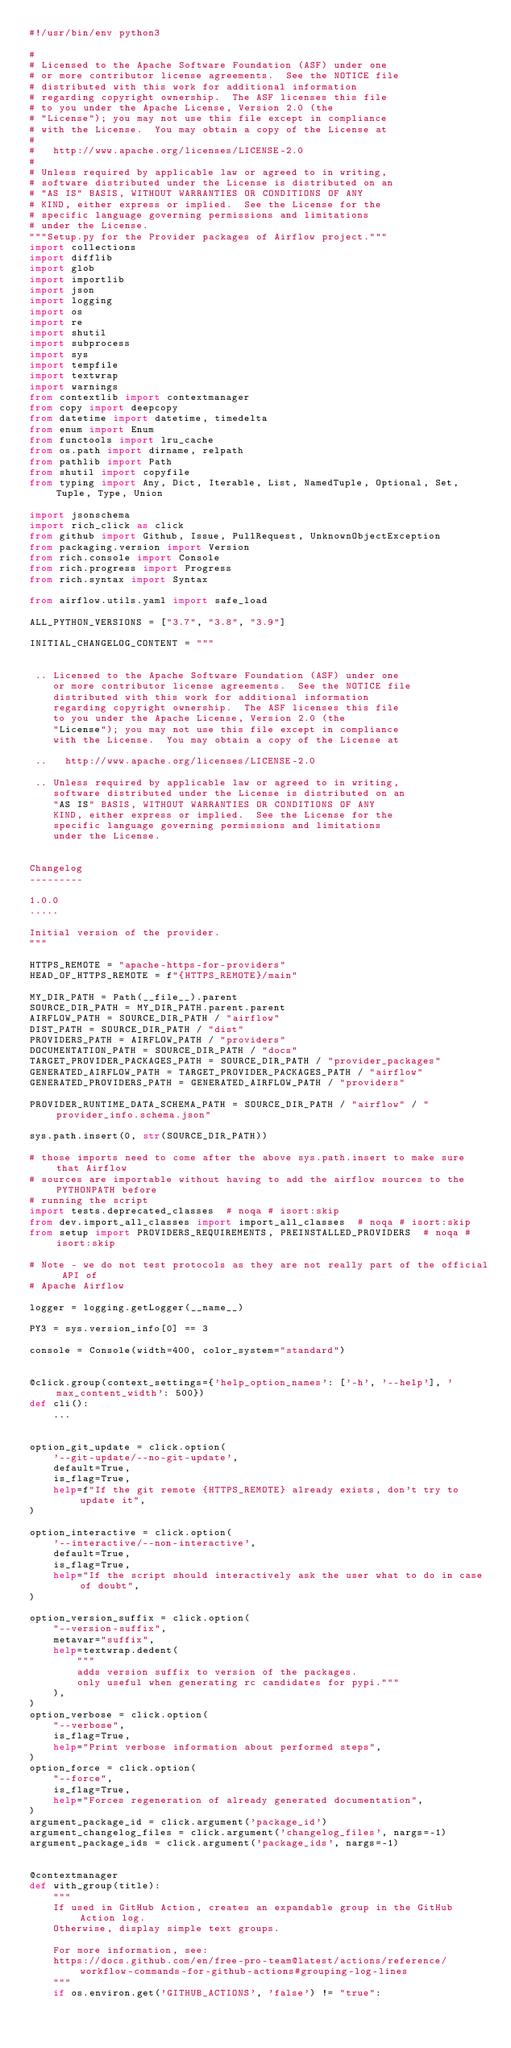Convert code to text. <code><loc_0><loc_0><loc_500><loc_500><_Python_>#!/usr/bin/env python3

#
# Licensed to the Apache Software Foundation (ASF) under one
# or more contributor license agreements.  See the NOTICE file
# distributed with this work for additional information
# regarding copyright ownership.  The ASF licenses this file
# to you under the Apache License, Version 2.0 (the
# "License"); you may not use this file except in compliance
# with the License.  You may obtain a copy of the License at
#
#   http://www.apache.org/licenses/LICENSE-2.0
#
# Unless required by applicable law or agreed to in writing,
# software distributed under the License is distributed on an
# "AS IS" BASIS, WITHOUT WARRANTIES OR CONDITIONS OF ANY
# KIND, either express or implied.  See the License for the
# specific language governing permissions and limitations
# under the License.
"""Setup.py for the Provider packages of Airflow project."""
import collections
import difflib
import glob
import importlib
import json
import logging
import os
import re
import shutil
import subprocess
import sys
import tempfile
import textwrap
import warnings
from contextlib import contextmanager
from copy import deepcopy
from datetime import datetime, timedelta
from enum import Enum
from functools import lru_cache
from os.path import dirname, relpath
from pathlib import Path
from shutil import copyfile
from typing import Any, Dict, Iterable, List, NamedTuple, Optional, Set, Tuple, Type, Union

import jsonschema
import rich_click as click
from github import Github, Issue, PullRequest, UnknownObjectException
from packaging.version import Version
from rich.console import Console
from rich.progress import Progress
from rich.syntax import Syntax

from airflow.utils.yaml import safe_load

ALL_PYTHON_VERSIONS = ["3.7", "3.8", "3.9"]

INITIAL_CHANGELOG_CONTENT = """


 .. Licensed to the Apache Software Foundation (ASF) under one
    or more contributor license agreements.  See the NOTICE file
    distributed with this work for additional information
    regarding copyright ownership.  The ASF licenses this file
    to you under the Apache License, Version 2.0 (the
    "License"); you may not use this file except in compliance
    with the License.  You may obtain a copy of the License at

 ..   http://www.apache.org/licenses/LICENSE-2.0

 .. Unless required by applicable law or agreed to in writing,
    software distributed under the License is distributed on an
    "AS IS" BASIS, WITHOUT WARRANTIES OR CONDITIONS OF ANY
    KIND, either express or implied.  See the License for the
    specific language governing permissions and limitations
    under the License.


Changelog
---------

1.0.0
.....

Initial version of the provider.
"""

HTTPS_REMOTE = "apache-https-for-providers"
HEAD_OF_HTTPS_REMOTE = f"{HTTPS_REMOTE}/main"

MY_DIR_PATH = Path(__file__).parent
SOURCE_DIR_PATH = MY_DIR_PATH.parent.parent
AIRFLOW_PATH = SOURCE_DIR_PATH / "airflow"
DIST_PATH = SOURCE_DIR_PATH / "dist"
PROVIDERS_PATH = AIRFLOW_PATH / "providers"
DOCUMENTATION_PATH = SOURCE_DIR_PATH / "docs"
TARGET_PROVIDER_PACKAGES_PATH = SOURCE_DIR_PATH / "provider_packages"
GENERATED_AIRFLOW_PATH = TARGET_PROVIDER_PACKAGES_PATH / "airflow"
GENERATED_PROVIDERS_PATH = GENERATED_AIRFLOW_PATH / "providers"

PROVIDER_RUNTIME_DATA_SCHEMA_PATH = SOURCE_DIR_PATH / "airflow" / "provider_info.schema.json"

sys.path.insert(0, str(SOURCE_DIR_PATH))

# those imports need to come after the above sys.path.insert to make sure that Airflow
# sources are importable without having to add the airflow sources to the PYTHONPATH before
# running the script
import tests.deprecated_classes  # noqa # isort:skip
from dev.import_all_classes import import_all_classes  # noqa # isort:skip
from setup import PROVIDERS_REQUIREMENTS, PREINSTALLED_PROVIDERS  # noqa # isort:skip

# Note - we do not test protocols as they are not really part of the official API of
# Apache Airflow

logger = logging.getLogger(__name__)

PY3 = sys.version_info[0] == 3

console = Console(width=400, color_system="standard")


@click.group(context_settings={'help_option_names': ['-h', '--help'], 'max_content_width': 500})
def cli():
    ...


option_git_update = click.option(
    '--git-update/--no-git-update',
    default=True,
    is_flag=True,
    help=f"If the git remote {HTTPS_REMOTE} already exists, don't try to update it",
)

option_interactive = click.option(
    '--interactive/--non-interactive',
    default=True,
    is_flag=True,
    help="If the script should interactively ask the user what to do in case of doubt",
)

option_version_suffix = click.option(
    "--version-suffix",
    metavar="suffix",
    help=textwrap.dedent(
        """
        adds version suffix to version of the packages.
        only useful when generating rc candidates for pypi."""
    ),
)
option_verbose = click.option(
    "--verbose",
    is_flag=True,
    help="Print verbose information about performed steps",
)
option_force = click.option(
    "--force",
    is_flag=True,
    help="Forces regeneration of already generated documentation",
)
argument_package_id = click.argument('package_id')
argument_changelog_files = click.argument('changelog_files', nargs=-1)
argument_package_ids = click.argument('package_ids', nargs=-1)


@contextmanager
def with_group(title):
    """
    If used in GitHub Action, creates an expandable group in the GitHub Action log.
    Otherwise, display simple text groups.

    For more information, see:
    https://docs.github.com/en/free-pro-team@latest/actions/reference/workflow-commands-for-github-actions#grouping-log-lines
    """
    if os.environ.get('GITHUB_ACTIONS', 'false') != "true":</code> 